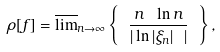Convert formula to latex. <formula><loc_0><loc_0><loc_500><loc_500>\rho [ f ] = \overline { \lim } _ { n \to \infty } \left \{ \ \frac { n \ \ln n } { | \ln | \xi _ { n } | \ | } \ \right \} ,</formula> 